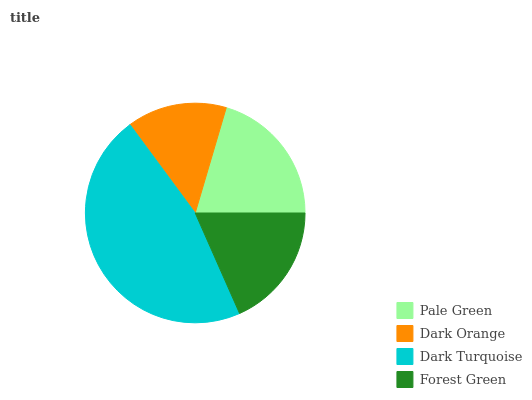Is Dark Orange the minimum?
Answer yes or no. Yes. Is Dark Turquoise the maximum?
Answer yes or no. Yes. Is Dark Turquoise the minimum?
Answer yes or no. No. Is Dark Orange the maximum?
Answer yes or no. No. Is Dark Turquoise greater than Dark Orange?
Answer yes or no. Yes. Is Dark Orange less than Dark Turquoise?
Answer yes or no. Yes. Is Dark Orange greater than Dark Turquoise?
Answer yes or no. No. Is Dark Turquoise less than Dark Orange?
Answer yes or no. No. Is Pale Green the high median?
Answer yes or no. Yes. Is Forest Green the low median?
Answer yes or no. Yes. Is Dark Turquoise the high median?
Answer yes or no. No. Is Dark Orange the low median?
Answer yes or no. No. 